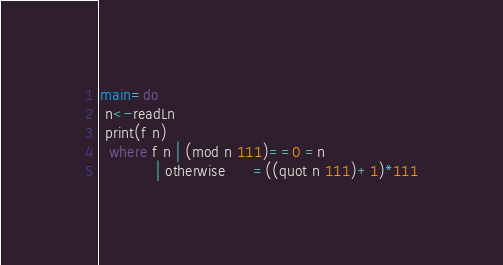<code> <loc_0><loc_0><loc_500><loc_500><_Haskell_>main=do
 n<-readLn
 print(f n)
  where f n | (mod n 111)==0 =n
            | otherwise      =((quot n 111)+1)*111</code> 